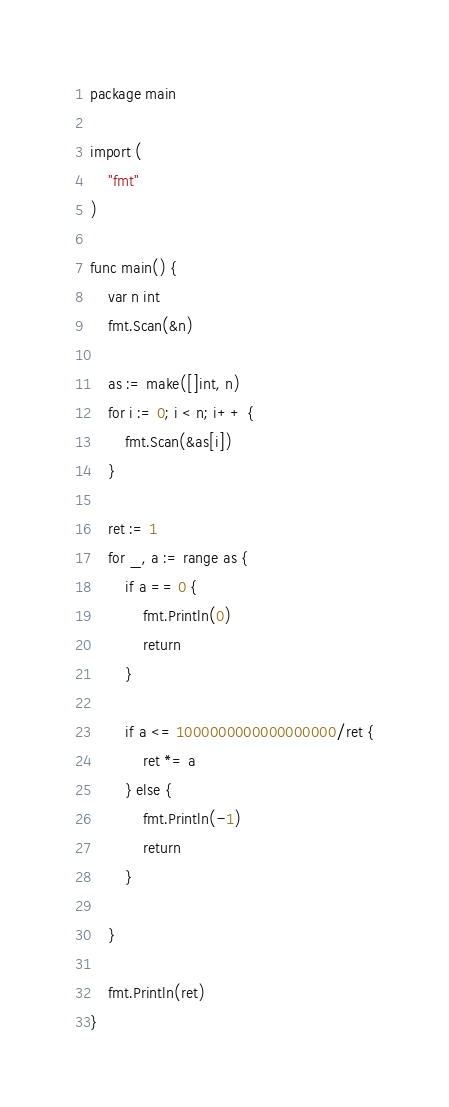<code> <loc_0><loc_0><loc_500><loc_500><_Go_>package main

import (
	"fmt"
)

func main() {
	var n int
	fmt.Scan(&n)

	as := make([]int, n)
	for i := 0; i < n; i++ {
		fmt.Scan(&as[i])
	}

	ret := 1
	for _, a := range as {
		if a == 0 {
			fmt.Println(0)
			return
		}

		if a <= 1000000000000000000/ret {
			ret *= a
		} else {
			fmt.Println(-1)
			return
		}

	}

	fmt.Println(ret)
}</code> 